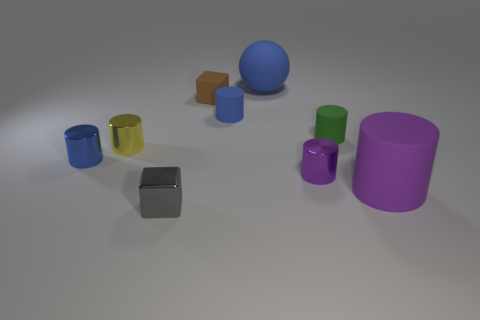Subtract 3 cylinders. How many cylinders are left? 3 Subtract all purple cylinders. How many cylinders are left? 4 Subtract all blue metallic cylinders. How many cylinders are left? 5 Subtract all green cylinders. Subtract all yellow balls. How many cylinders are left? 5 Add 1 blue metallic cubes. How many objects exist? 10 Subtract all cylinders. How many objects are left? 3 Subtract 1 gray cubes. How many objects are left? 8 Subtract all gray shiny things. Subtract all tiny blue rubber cylinders. How many objects are left? 7 Add 9 green matte cylinders. How many green matte cylinders are left? 10 Add 2 large blue metal cubes. How many large blue metal cubes exist? 2 